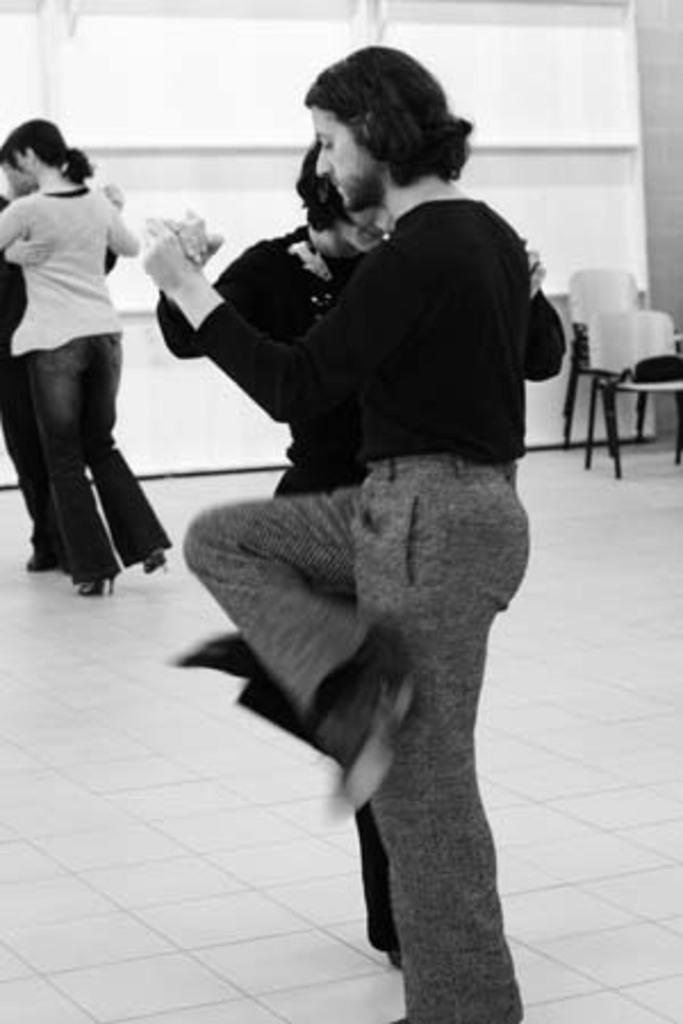What are the people in the image doing? The people in the image are holding each other and dancing. What objects are present in the image besides the people? There are chairs and glass windows in the image. How are the glass windows positioned in the image? The glass windows are attached to a wall. What type of yoke is being used by the people in the image? There is no yoke present in the image; the people are dancing and holding each other. 